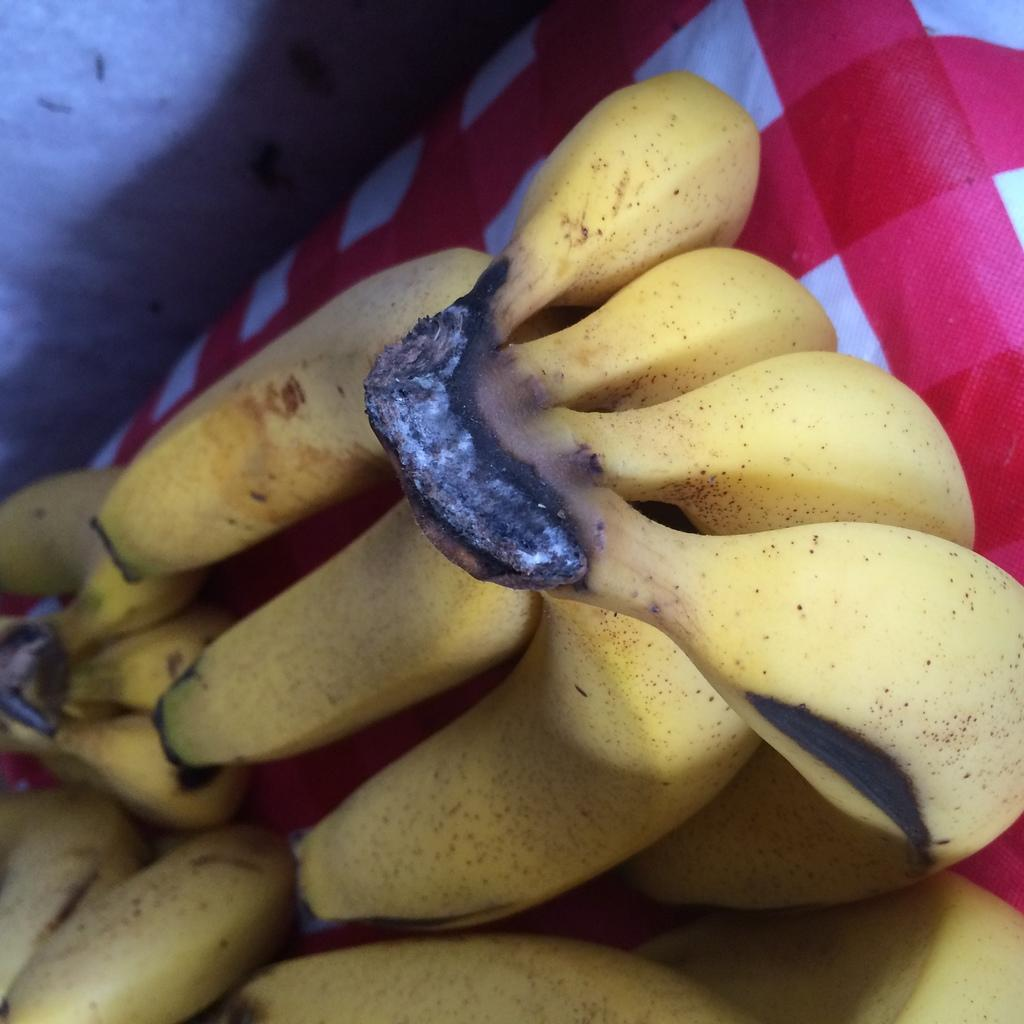What type of fruit is present in the image? There are bananas in the image. What is the other object in the image besides the bananas? There is a cloth in the image. What can be seen in the background of the image? There is a wall in the image. What type of competition is taking place in the image? There is no competition present in the image; it only features bananas and a cloth. Can you tell me how many turkeys are visible in the image? There are no turkeys present in the image; it only features bananas and a cloth. 